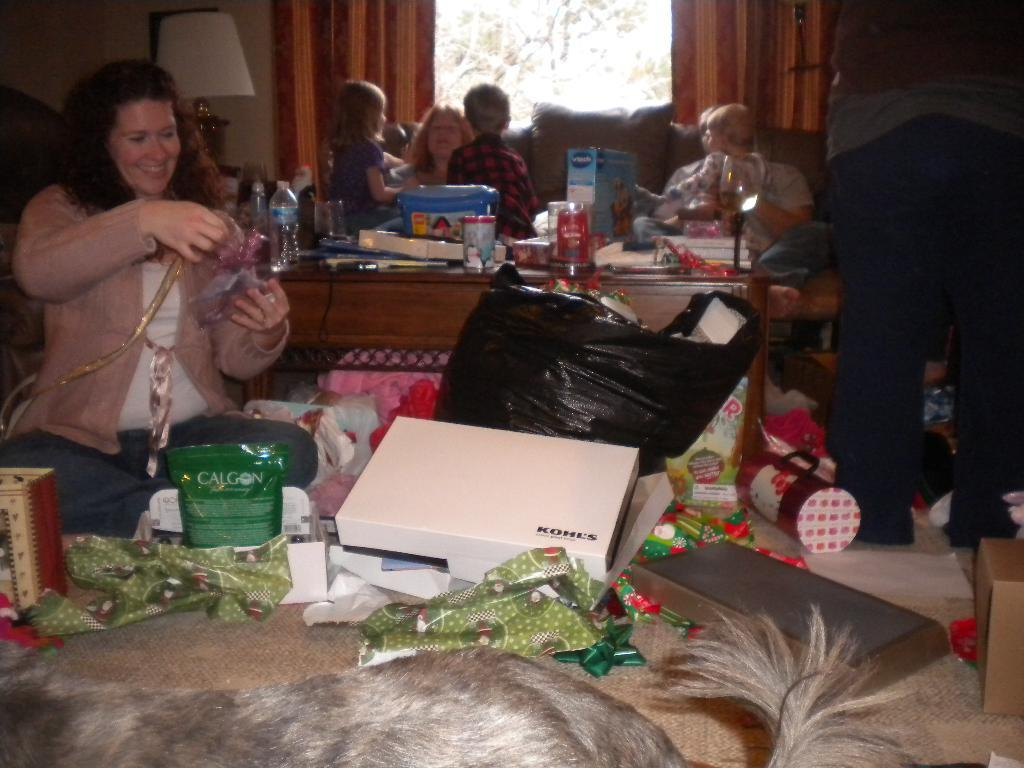What are the people in the room doing? The people in the room are sitting. What is on the table in the room? There is a table in the room with water bottles, cups, and books on it. What else can be found in the room? There are boxes and paper wraps in the room. Is there any living creature other than humans in the room? Yes, there is a dog in the room. What type of discussion is happening between the people in the room? There is no indication of a discussion happening in the image. Can you see a wrench on the table or anywhere in the room? No, there is no wrench present in the image. 